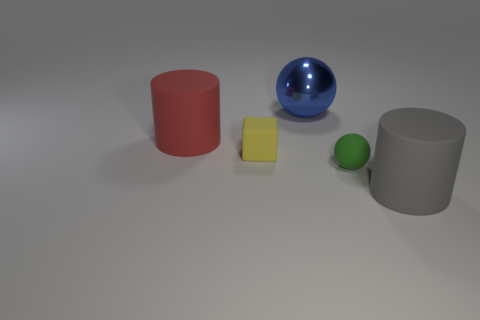How many objects are either rubber cylinders that are to the left of the small yellow matte thing or large blue metallic objects?
Offer a very short reply. 2. What number of things are either tiny gray rubber things or rubber objects to the left of the big gray matte cylinder?
Your answer should be compact. 3. What number of yellow metal things have the same size as the red cylinder?
Provide a short and direct response. 0. Is the number of big cylinders that are behind the tiny ball less than the number of blocks on the right side of the blue sphere?
Your response must be concise. No. What number of metal objects are either tiny objects or brown cubes?
Provide a short and direct response. 0. What is the shape of the gray thing?
Make the answer very short. Cylinder. There is a yellow cube that is the same size as the green rubber sphere; what is its material?
Give a very brief answer. Rubber. What number of small objects are green matte balls or gray matte objects?
Provide a short and direct response. 1. Is there a big cyan matte ball?
Give a very brief answer. No. There is a red cylinder that is the same material as the cube; what size is it?
Your response must be concise. Large. 